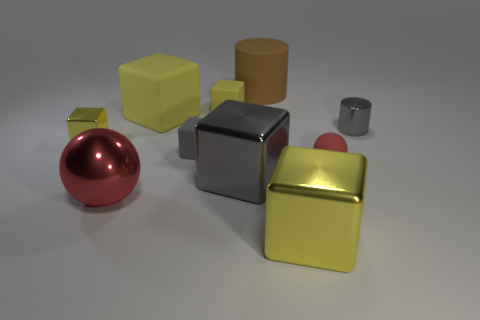What could be the possible use for each of these objects if they were real? Imagining these objects as real, the glossy red sphere could be a decorative piece or a child's ball. The gold and yellow cubes might serve as toy blocks or modern art sculptures. The silver cube could be a futuristic container or a metal cast for machinery. The brown cylinder might function as a storage canister, while the small gray cylinder could be a cup or a container for small items. 